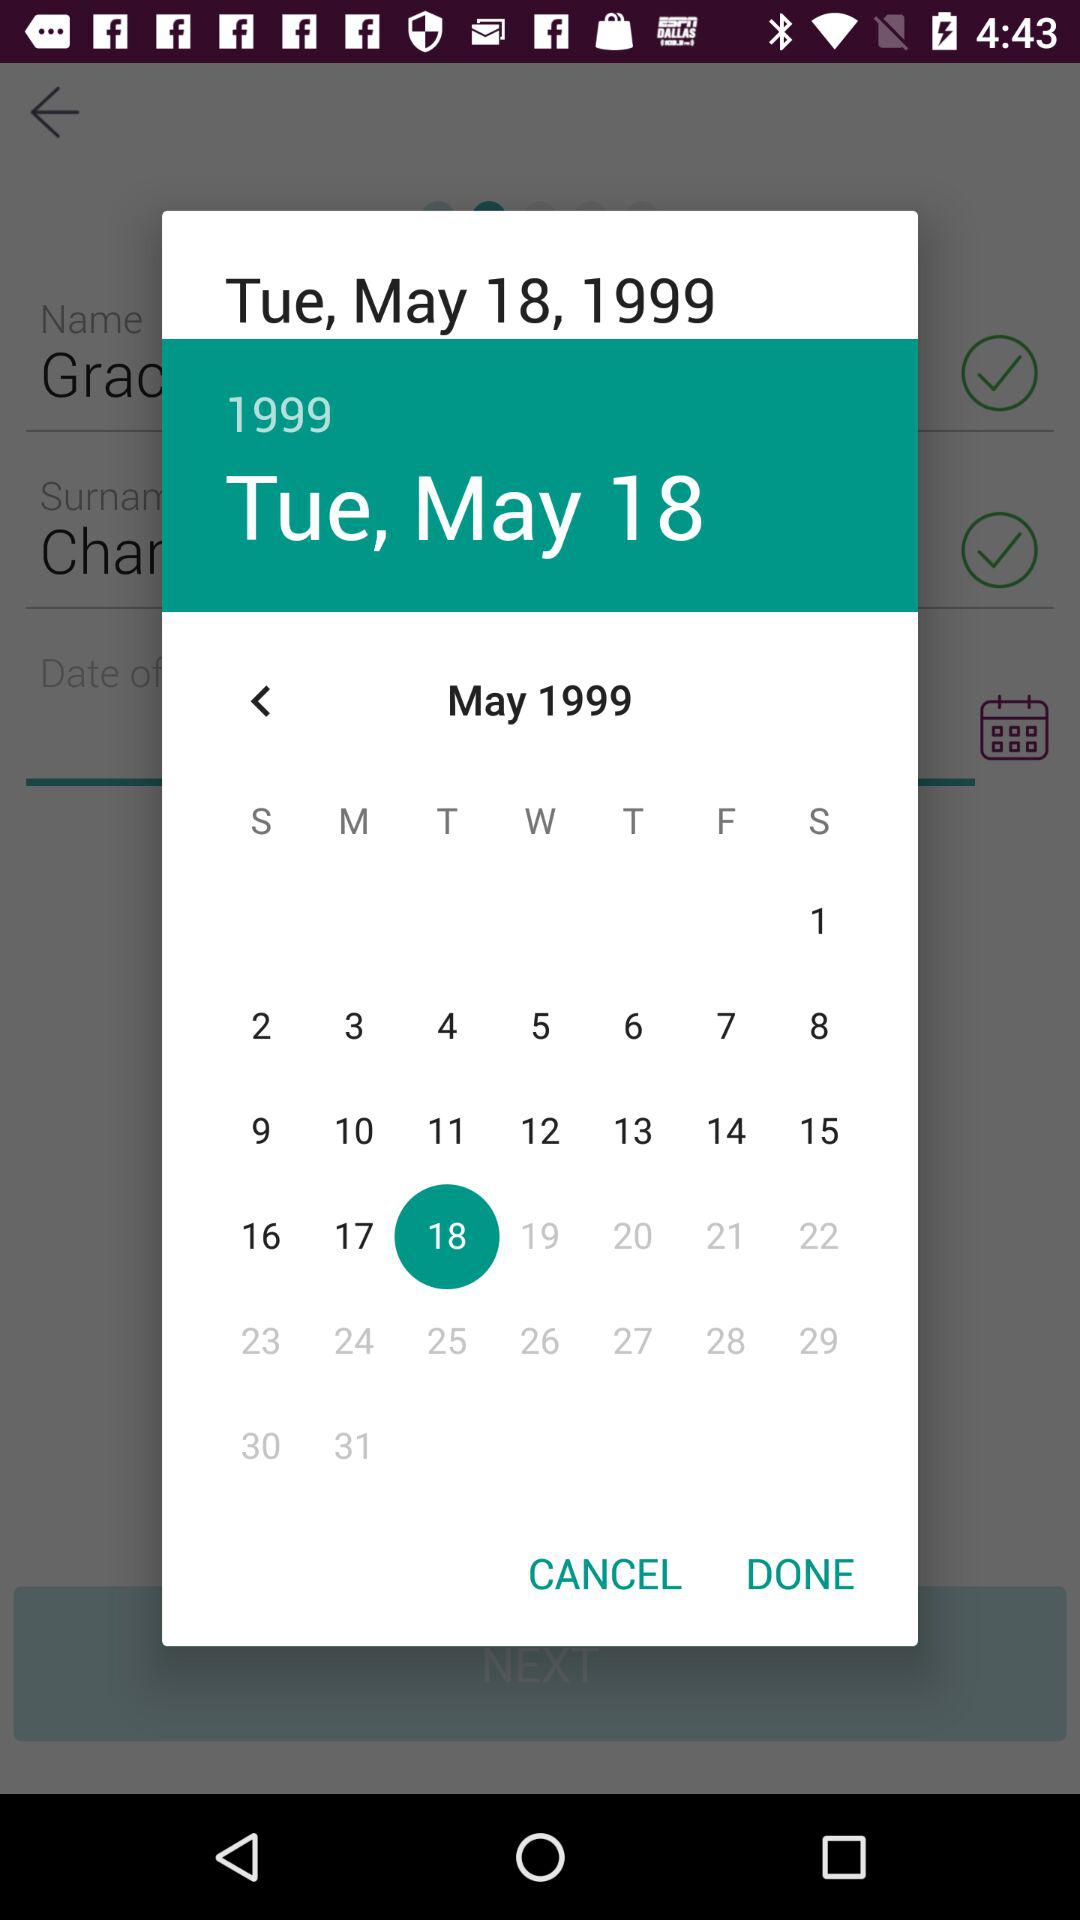Which gender is selected?
When the provided information is insufficient, respond with <no answer>. <no answer> 